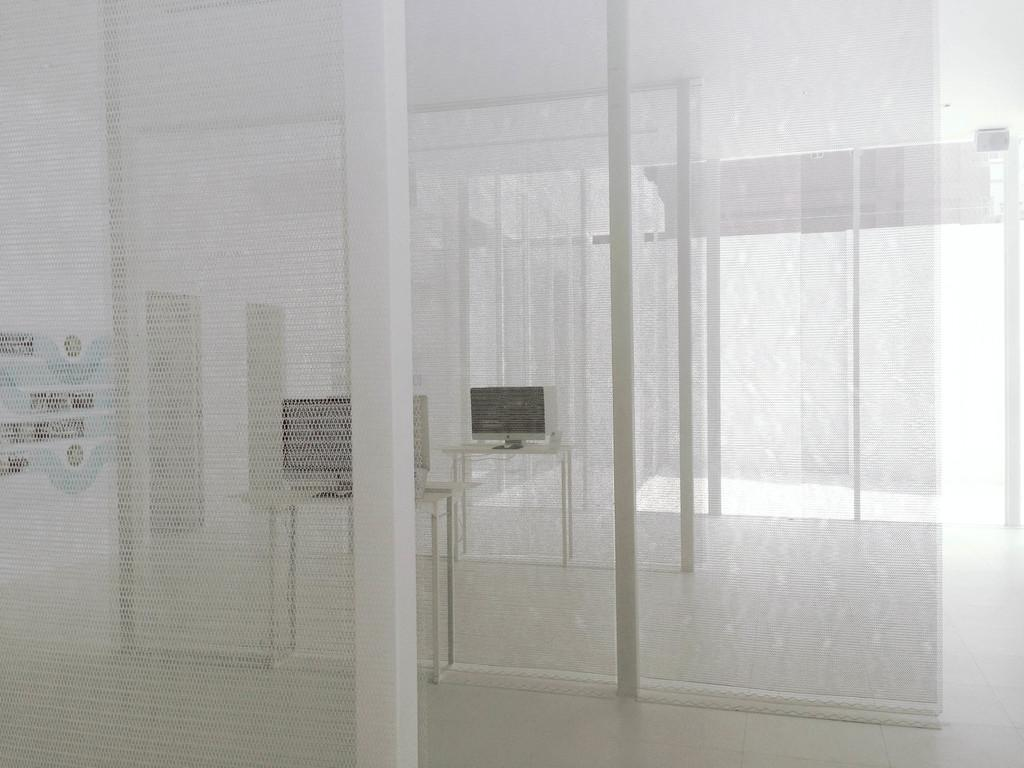What is the color of the interior of the house in the image? The interior of the house is white in color. How are the rooms separated in the house? There are net walls dividing the rooms. What piece of furniture can be seen in the house? There is a table in the house. What electronic device is present on the table? A computer system is present on the table. What type of crayon is being used to draw on the cushion in the image? There is no crayon or cushion present in the image. 